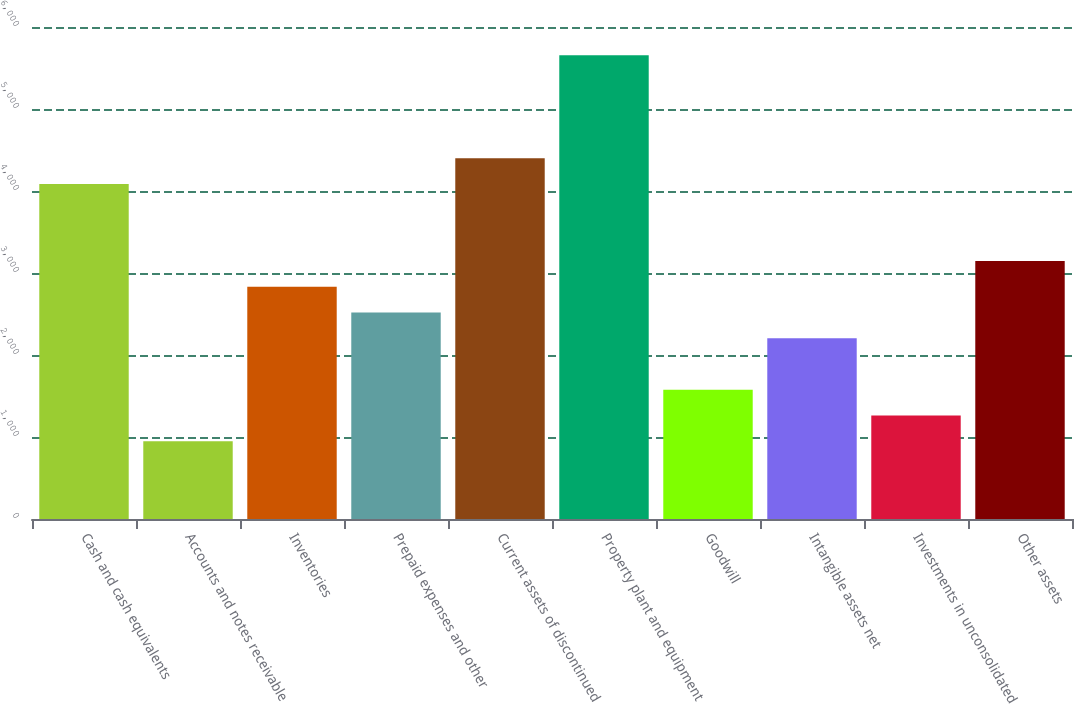Convert chart to OTSL. <chart><loc_0><loc_0><loc_500><loc_500><bar_chart><fcel>Cash and cash equivalents<fcel>Accounts and notes receivable<fcel>Inventories<fcel>Prepaid expenses and other<fcel>Current assets of discontinued<fcel>Property plant and equipment<fcel>Goodwill<fcel>Intangible assets net<fcel>Investments in unconsolidated<fcel>Other assets<nl><fcel>4086.7<fcel>947.7<fcel>2831.1<fcel>2517.2<fcel>4400.6<fcel>5656.2<fcel>1575.5<fcel>2203.3<fcel>1261.6<fcel>3145<nl></chart> 